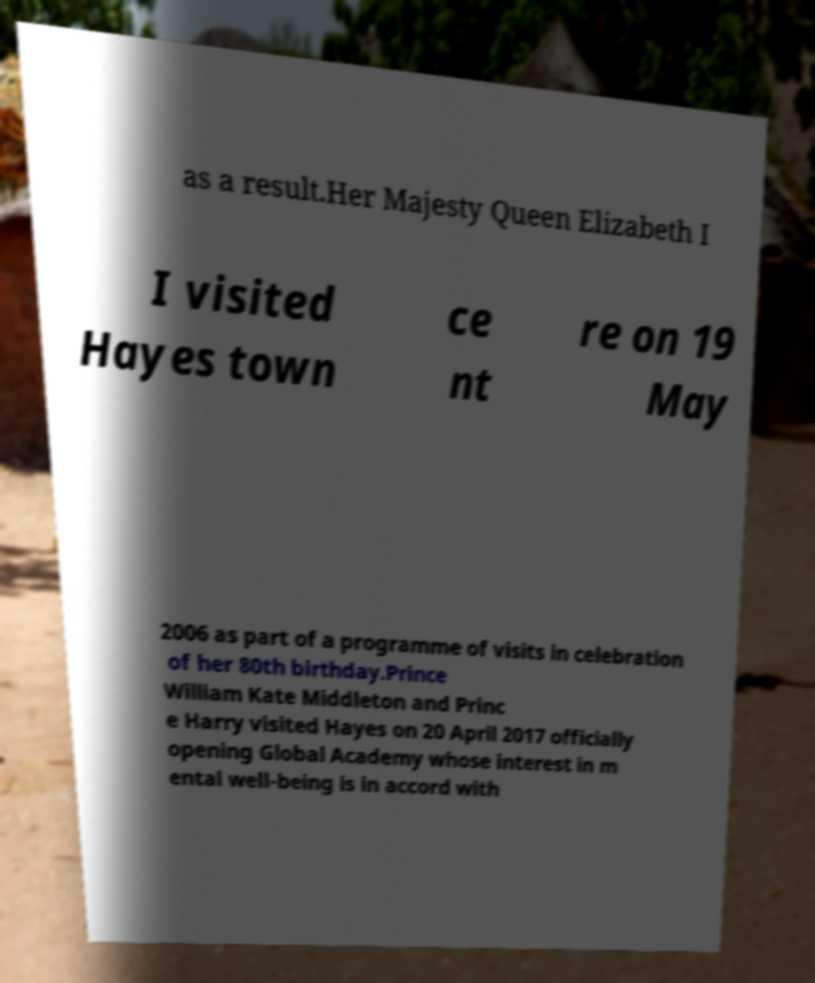There's text embedded in this image that I need extracted. Can you transcribe it verbatim? as a result.Her Majesty Queen Elizabeth I I visited Hayes town ce nt re on 19 May 2006 as part of a programme of visits in celebration of her 80th birthday.Prince William Kate Middleton and Princ e Harry visited Hayes on 20 April 2017 officially opening Global Academy whose interest in m ental well-being is in accord with 